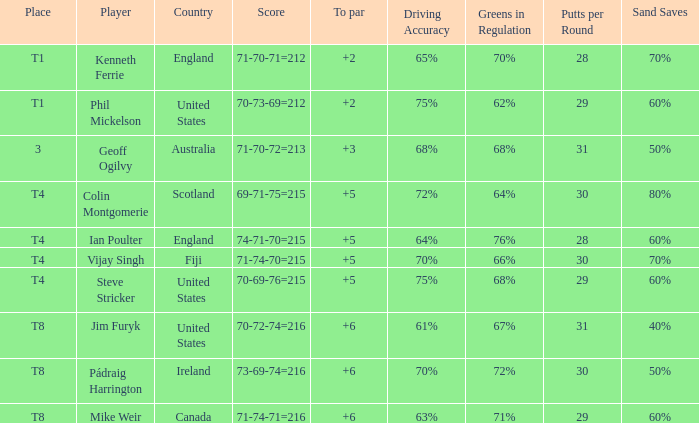Parse the table in full. {'header': ['Place', 'Player', 'Country', 'Score', 'To par', 'Driving Accuracy', 'Greens in Regulation', 'Putts per Round', 'Sand Saves'], 'rows': [['T1', 'Kenneth Ferrie', 'England', '71-70-71=212', '+2', '65%', '70%', '28', '70%'], ['T1', 'Phil Mickelson', 'United States', '70-73-69=212', '+2', '75%', '62%', '29', '60%'], ['3', 'Geoff Ogilvy', 'Australia', '71-70-72=213', '+3', '68%', '68%', '31', '50%'], ['T4', 'Colin Montgomerie', 'Scotland', '69-71-75=215', '+5', '72%', '64%', '30', '80%'], ['T4', 'Ian Poulter', 'England', '74-71-70=215', '+5', '64%', '76%', '28', '60%'], ['T4', 'Vijay Singh', 'Fiji', '71-74-70=215', '+5', '70%', '66%', '30', '70%'], ['T4', 'Steve Stricker', 'United States', '70-69-76=215', '+5', '75%', '68%', '29', '60%'], ['T8', 'Jim Furyk', 'United States', '70-72-74=216', '+6', '61%', '67%', '31', '40%'], ['T8', 'Pádraig Harrington', 'Ireland', '73-69-74=216', '+6', '70%', '72%', '30', '50%'], ['T8', 'Mike Weir', 'Canada', '71-74-71=216', '+6', '63%', '71%', '29', '60%']]} What score to par did Mike Weir have? 6.0. 